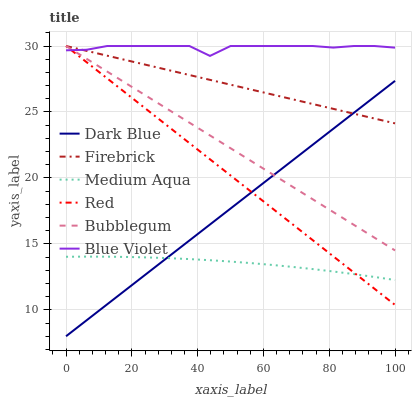Does Bubblegum have the minimum area under the curve?
Answer yes or no. No. Does Bubblegum have the maximum area under the curve?
Answer yes or no. No. Is Dark Blue the smoothest?
Answer yes or no. No. Is Dark Blue the roughest?
Answer yes or no. No. Does Bubblegum have the lowest value?
Answer yes or no. No. Does Dark Blue have the highest value?
Answer yes or no. No. Is Medium Aqua less than Bubblegum?
Answer yes or no. Yes. Is Blue Violet greater than Dark Blue?
Answer yes or no. Yes. Does Medium Aqua intersect Bubblegum?
Answer yes or no. No. 